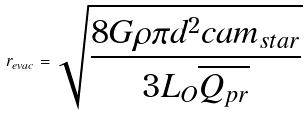Convert formula to latex. <formula><loc_0><loc_0><loc_500><loc_500>r _ { e v a c } = \sqrt { \frac { 8 G \rho \pi d ^ { 2 } c a m _ { s t a r } } { 3 L _ { O } \overline { Q _ { p r } } } }</formula> 